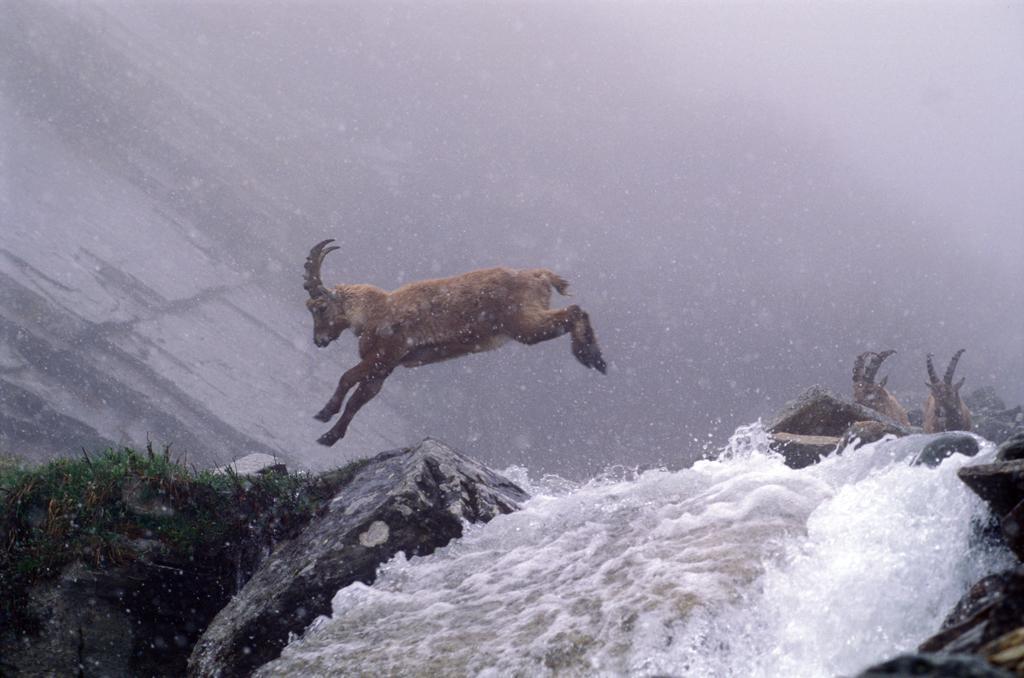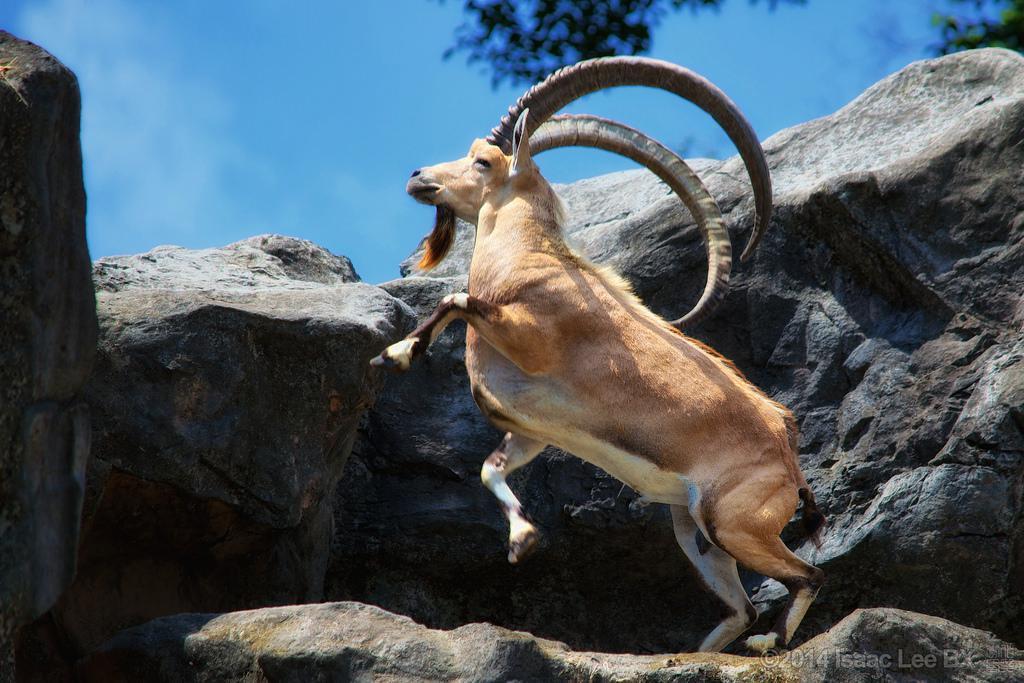The first image is the image on the left, the second image is the image on the right. Assess this claim about the two images: "in one of the images, the ram with horns is leaping upwards and racing towards the left side.". Correct or not? Answer yes or no. Yes. The first image is the image on the left, the second image is the image on the right. Assess this claim about the two images: "A cloven animal is leaping and all four hooves are off of the ground.". Correct or not? Answer yes or no. Yes. 